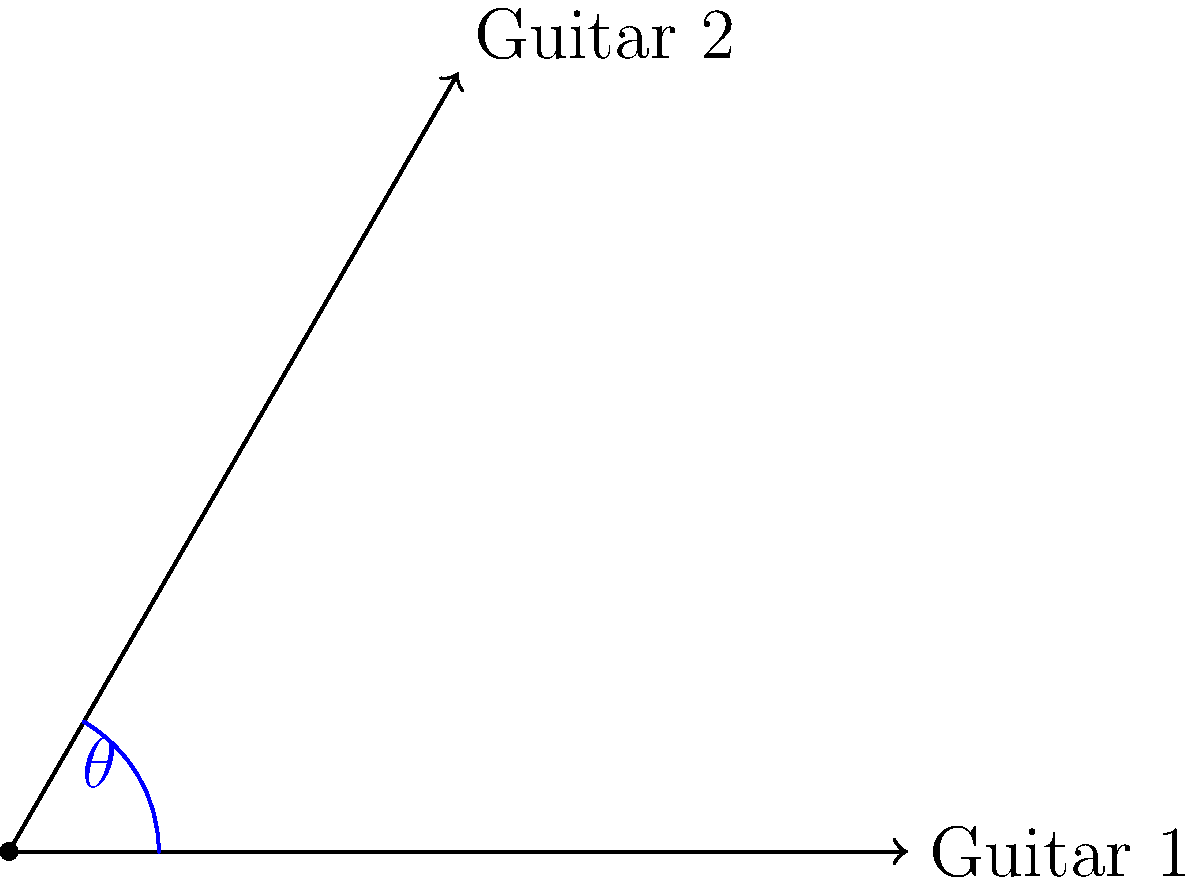In a unique stage setup, two guitar necks are positioned at different orientations. Guitar 1 is aligned with the positive x-axis, while Guitar 2 is positioned at an angle. If the coordinates of the tip of Guitar 1's neck are (3,0) and the coordinates of the tip of Guitar 2's neck are (1.5,2.6), what is the angle $\theta$ (in degrees) between the two guitar necks? To find the angle between the two guitar necks, we can use the arctangent function. Here's the step-by-step solution:

1) Guitar 1 is aligned with the x-axis, so its angle with respect to the x-axis is 0°.

2) For Guitar 2, we need to calculate its angle with respect to the x-axis:
   $\theta = \arctan(\frac{y}{x})$
   where $x$ and $y$ are the coordinates of Guitar 2's neck tip.

3) Plugging in the values:
   $\theta = \arctan(\frac{2.6}{1.5})$

4) Calculate this value:
   $\theta \approx 60.0152°$

5) Since this is the angle between Guitar 2 and the x-axis (which Guitar 1 is aligned with), this is also the angle between the two guitar necks.

6) Round to the nearest degree:
   $\theta \approx 60°$
Answer: $60°$ 